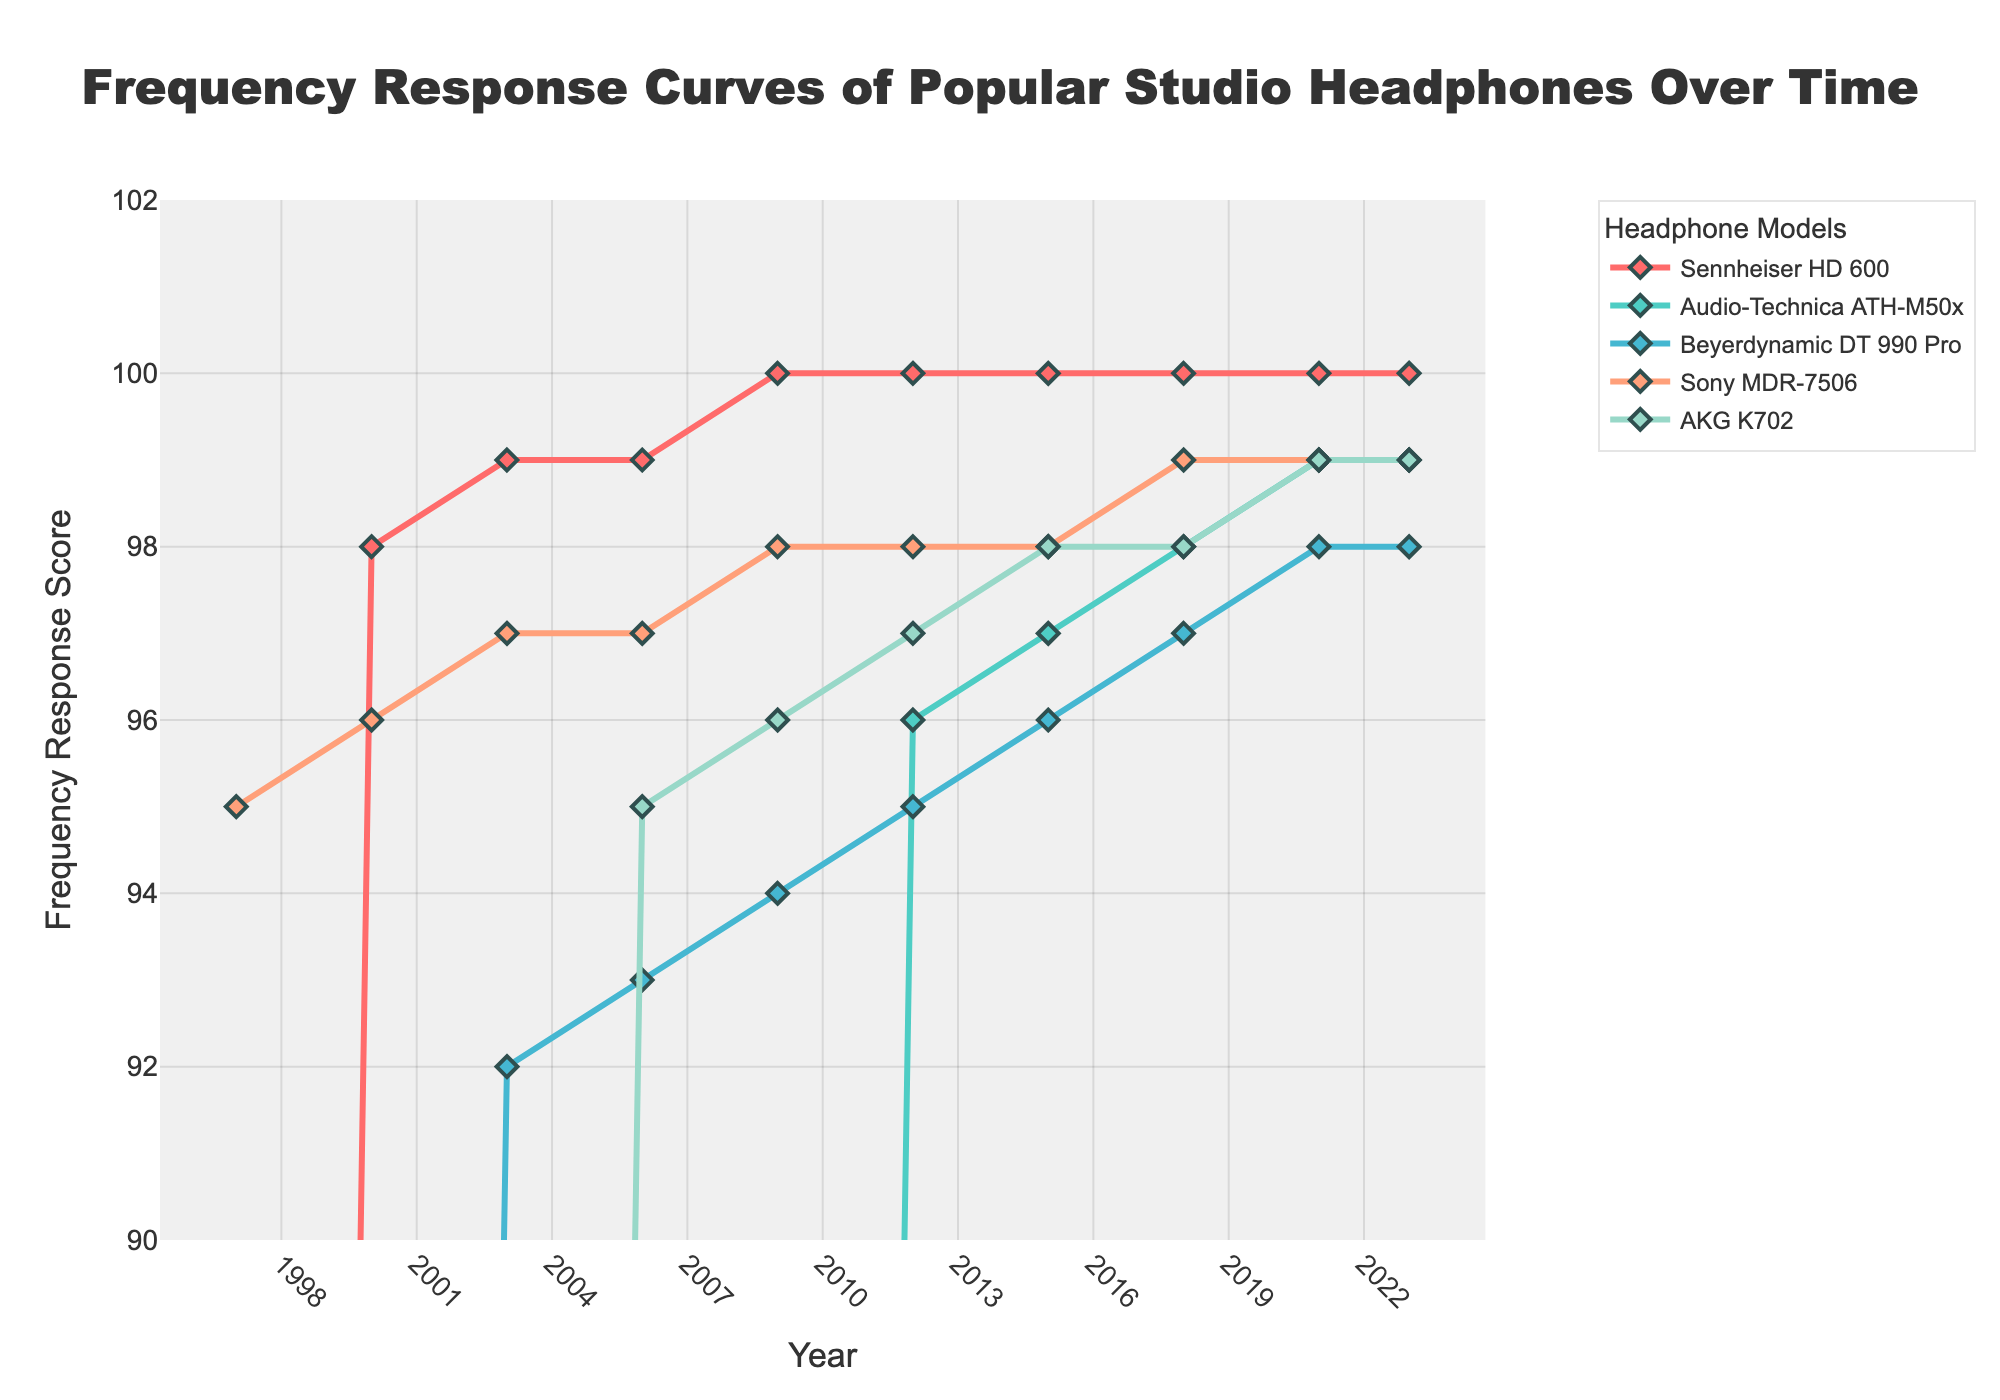What is the trend in the frequency response score of the Sennheiser HD 600 over time? The chart shows that the frequency response score of the Sennheiser HD 600 started at 0 in 1997 and consistently increased over time, reaching 100 in 2009 and remained at that level through 2023.
Answer: It increased steadily and stabilized at 100 by 2009 Which headphone model had the latest increase in frequency response scores? The Audio-Technica ATH-M50x had its first non-zero frequency response score in 2012, indicating the latest increase among the models listed.
Answer: Audio-Technica ATH-M50x Between the Audio-Technica ATH-M50x and the Sony MDR-7506, which model had a higher frequency response score in 2015? In 2015, the Audio-Technica ATH-M50x scored 97 and the Sony MDR-7506 scored 98. Comparing these values, the Sony MDR-7506 had a higher score.
Answer: Sony MDR-7506 What is the overall trend in the frequency response score for the Beyerdynamic DT 990 Pro from 1997 to 2023? The Beyerdynamic DT 990 Pro started with a score of 0 in 1997, increased consistently through the years, reaching a score of 98 by 2021, and remained stable at 98 through 2023.
Answer: Increasing steadily What was the most significant increase in frequency response score for the AKG K702, and in what year did it occur? The AKG K702 had its most significant increase between 2003 and 2006, rising from 0 to 95. This is an increase of 95 points in that period.
Answer: Between 2003 and 2006 How does the frequency response score of the Sennheiser HD 600 in 2000 compare with that of the Beyerdynamic DT 990 Pro in 2009? In 2000, the Sennheiser HD 600 scored 98, whereas the Beyerdynamic DT 990 Pro scored 94 in 2009. Comparing these scores, the Sennheiser HD 600 in 2000 is higher.
Answer: Sennheiser HD 600 in 2000 is higher What can you infer about the popularity or performance improvements of the AKG K702 over time based on the frequency response scores? The AKG K702 has shown a steady improvement from a score of 0 in 1997 to 99 by 2021, indicating consistent enhancements over time.
Answer: Consistent enhancements over time In 2023, do all headphones have the same frequency response score? If not, which ones differ? In 2023, the Sennheiser HD 600, Beyerdynamic DT 990 Pro, Sony MDR-7506, and AKG K702 all have a frequency response score of 100, except for the Audio-Technica ATH-M50x, which has a score of 99.
Answer: Audio-Technica ATH-M50x 